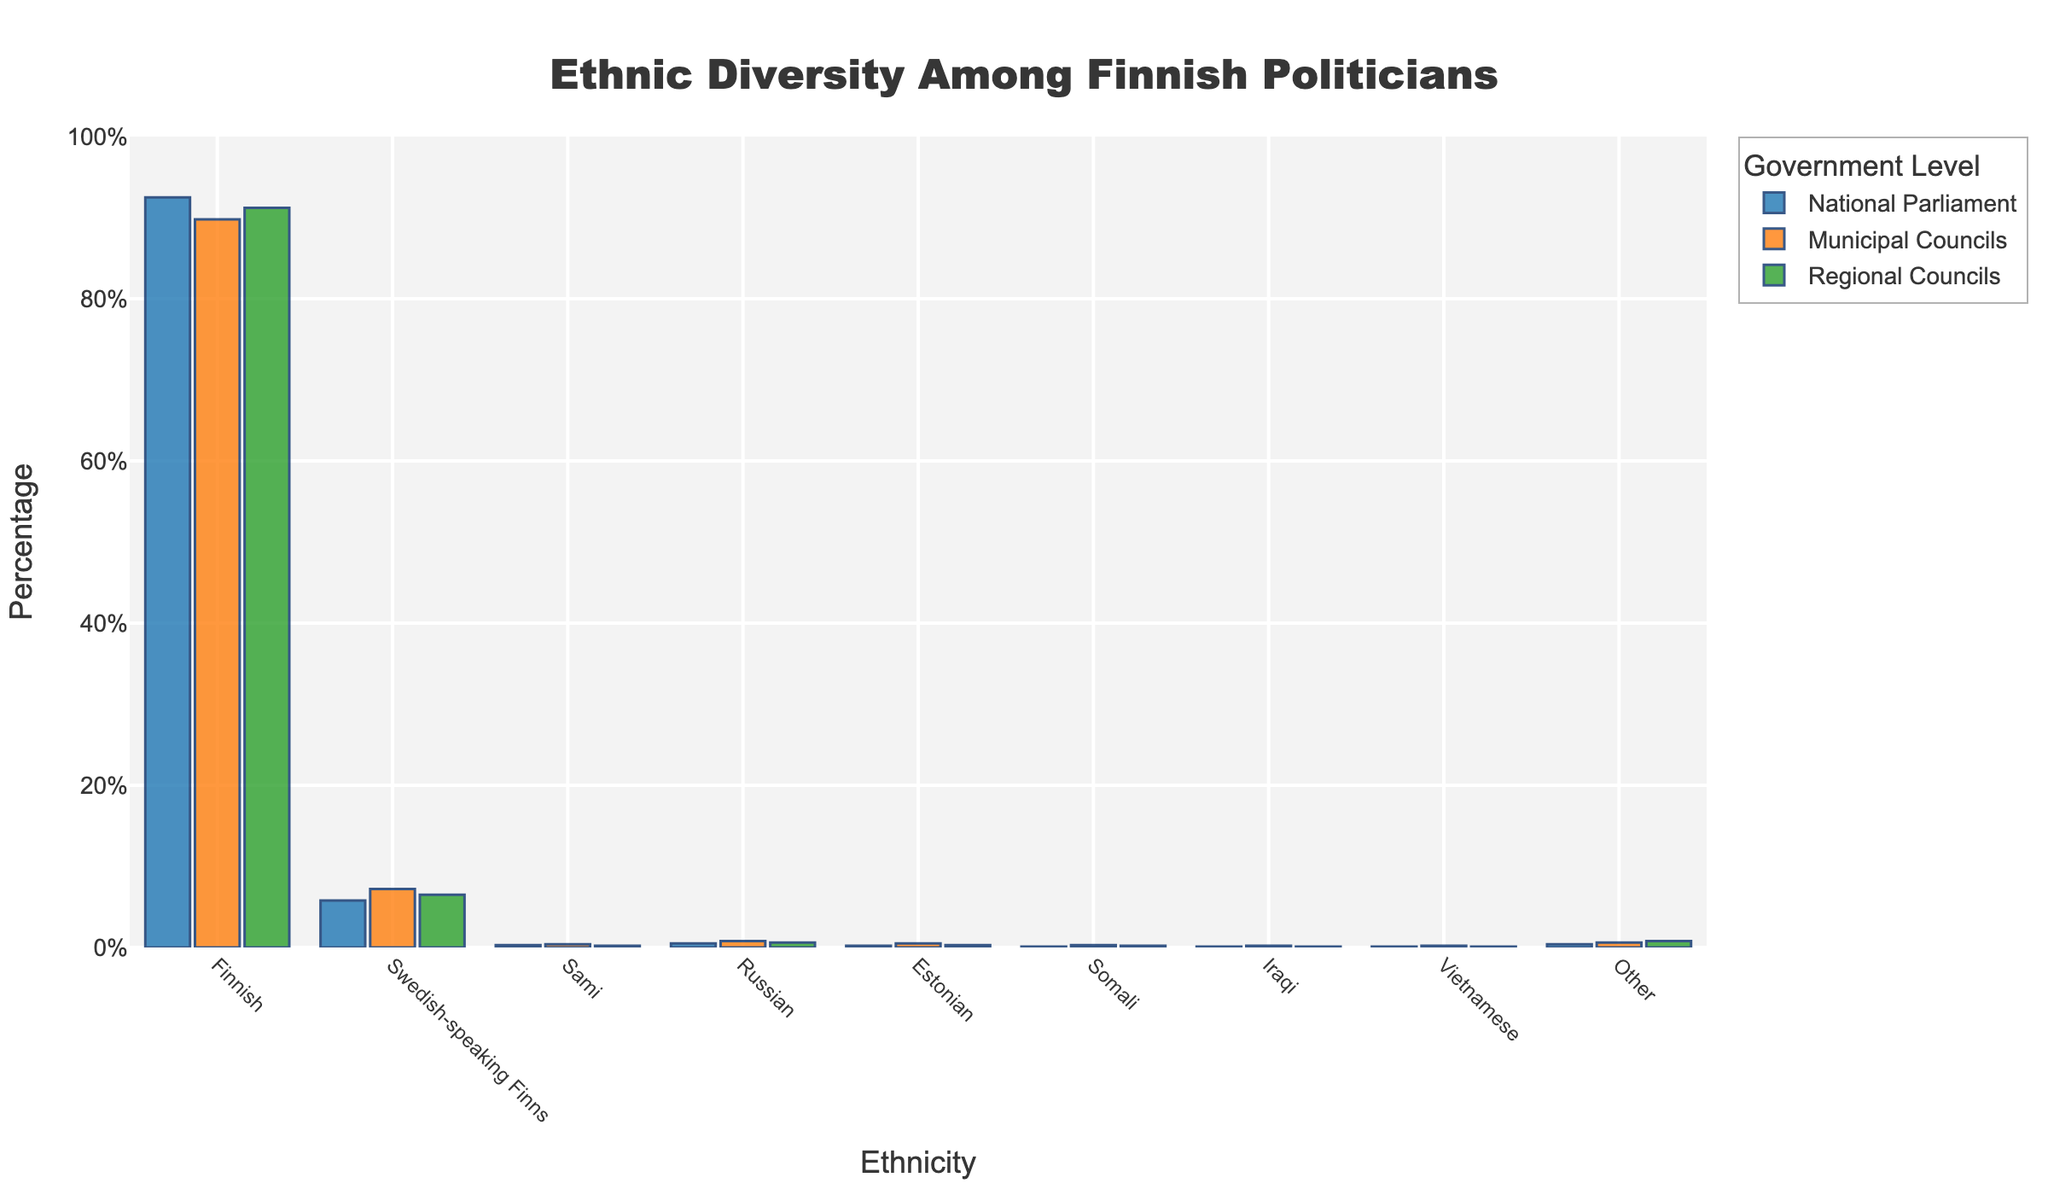Which ethnicity has the highest percentage of representation in the National Parliament? Look at the highest bar within the 'National Parliament' category. The 'Finnish' ethnicity clearly has the highest bar in this category.
Answer: Finnish Which government level shows the highest percentage of representation for Swedish-speaking Finns? Compare the heights of bars representing Swedish-speaking Finns across the three government levels. The 'Municipal Councils' bar is the highest for this group.
Answer: Municipal Councils What is the combined percentage of Sami representation across all three levels of government? Add the percentages for the Sami ethnicity in the National Parliament, Municipal Councils, and Regional Councils levels: 0.3% + 0.4% + 0.2%.
Answer: 0.9% Is the representation of Russian ethnicity greater than Estonian ethnicity across all levels of government? Compare the bars for the Russian and Estonian ethnicities in each government level. For each level, the Russian percentage is higher (0.5% vs 0.2% in National Parliament, 0.8% vs 0.5% in Municipal Councils, 0.6% vs 0.3% in Regional Councils).
Answer: Yes Which ethnicity has the smallest difference in percentage between National Parliament and Regional Councils? Calculate the difference for each ethnicity between National Parliament and Regional Councils, and find the smallest difference: Finnish (1.3%), Swedish-speaking Finns (0.7%), Sami (0.1%), Russian (0.1%), Estonian (0.1%), Somali (0.1%), Iraqi (0%), Vietnamese (0%), Other (0.4%).
Answer: Iraqi and Vietnamese Does the Municipal Councils level show a higher representation percentage for Somali ethnicity compared to the Regional Councils level? Compare the heights of the bars for Somali ethnicity between Municipal Councils (0.3%) and Regional Councils (0.2%). The bar for Municipal Councils is higher.
Answer: Yes Which ethnicity shows the most uniform distribution across all three levels of government? Look for the ethnicity with the smallest range between the highest and lowest percentages across the three levels. Both Iraqi and Vietnamese have 0.1% in National Parliament, 0.2% in Municipal Councils, and 0.1% in Regional Councils, making them the most uniformly distributed.
Answer: Iraqi and Vietnamese 